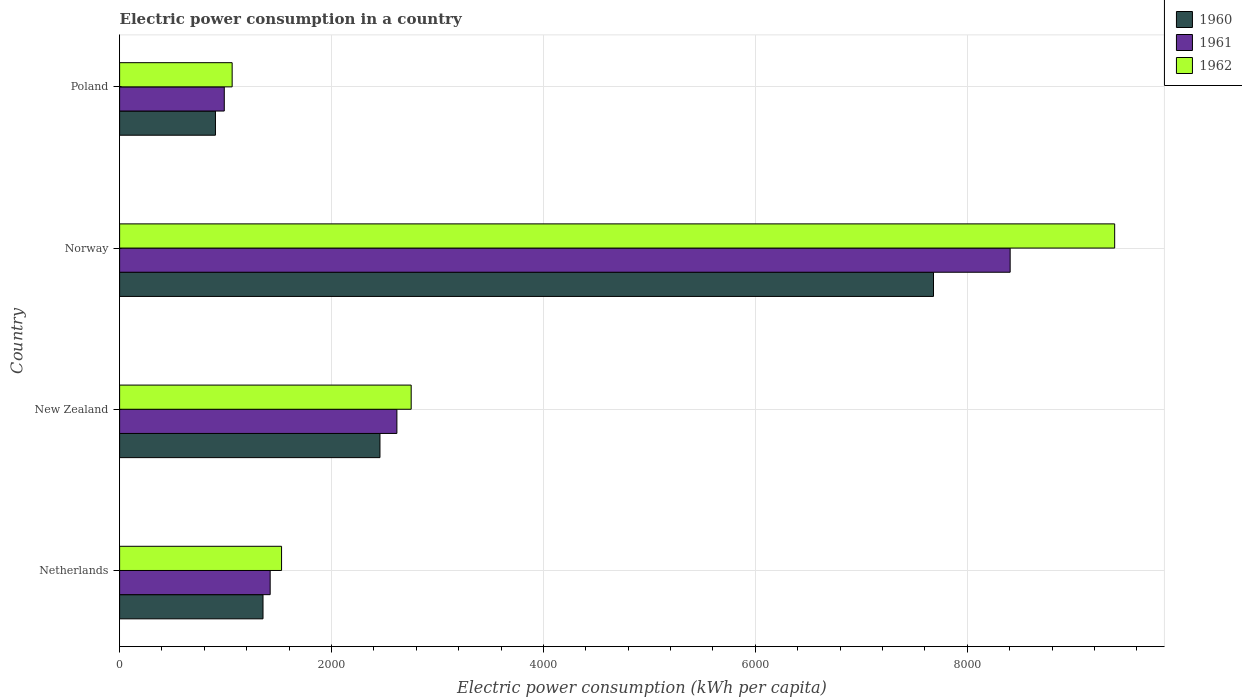How many bars are there on the 1st tick from the top?
Offer a very short reply. 3. What is the label of the 3rd group of bars from the top?
Ensure brevity in your answer.  New Zealand. What is the electric power consumption in in 1962 in Netherlands?
Your answer should be compact. 1528.5. Across all countries, what is the maximum electric power consumption in in 1961?
Your answer should be very brief. 8404.62. Across all countries, what is the minimum electric power consumption in in 1960?
Keep it short and to the point. 904.57. In which country was the electric power consumption in in 1961 maximum?
Give a very brief answer. Norway. In which country was the electric power consumption in in 1960 minimum?
Keep it short and to the point. Poland. What is the total electric power consumption in in 1962 in the graph?
Make the answer very short. 1.47e+04. What is the difference between the electric power consumption in in 1962 in Netherlands and that in Norway?
Ensure brevity in your answer.  -7862.48. What is the difference between the electric power consumption in in 1962 in Poland and the electric power consumption in in 1961 in Netherlands?
Give a very brief answer. -358.86. What is the average electric power consumption in in 1961 per country?
Provide a short and direct response. 3357.61. What is the difference between the electric power consumption in in 1962 and electric power consumption in in 1960 in New Zealand?
Provide a short and direct response. 294.61. What is the ratio of the electric power consumption in in 1962 in Netherlands to that in Norway?
Ensure brevity in your answer.  0.16. Is the electric power consumption in in 1960 in New Zealand less than that in Poland?
Ensure brevity in your answer.  No. What is the difference between the highest and the second highest electric power consumption in in 1961?
Offer a very short reply. 5787.77. What is the difference between the highest and the lowest electric power consumption in in 1961?
Offer a terse response. 7416.7. Is the sum of the electric power consumption in in 1960 in Netherlands and New Zealand greater than the maximum electric power consumption in in 1961 across all countries?
Your answer should be very brief. No. What does the 3rd bar from the top in New Zealand represents?
Make the answer very short. 1960. Is it the case that in every country, the sum of the electric power consumption in in 1961 and electric power consumption in in 1962 is greater than the electric power consumption in in 1960?
Provide a succinct answer. Yes. How many bars are there?
Ensure brevity in your answer.  12. Does the graph contain any zero values?
Your answer should be very brief. No. How are the legend labels stacked?
Give a very brief answer. Vertical. What is the title of the graph?
Provide a short and direct response. Electric power consumption in a country. What is the label or title of the X-axis?
Your response must be concise. Electric power consumption (kWh per capita). What is the Electric power consumption (kWh per capita) of 1960 in Netherlands?
Keep it short and to the point. 1353.4. What is the Electric power consumption (kWh per capita) in 1961 in Netherlands?
Offer a terse response. 1421.03. What is the Electric power consumption (kWh per capita) in 1962 in Netherlands?
Make the answer very short. 1528.5. What is the Electric power consumption (kWh per capita) in 1960 in New Zealand?
Your answer should be very brief. 2457.21. What is the Electric power consumption (kWh per capita) in 1961 in New Zealand?
Provide a short and direct response. 2616.85. What is the Electric power consumption (kWh per capita) of 1962 in New Zealand?
Your answer should be compact. 2751.81. What is the Electric power consumption (kWh per capita) of 1960 in Norway?
Provide a succinct answer. 7681.14. What is the Electric power consumption (kWh per capita) in 1961 in Norway?
Keep it short and to the point. 8404.62. What is the Electric power consumption (kWh per capita) in 1962 in Norway?
Offer a terse response. 9390.98. What is the Electric power consumption (kWh per capita) of 1960 in Poland?
Your answer should be compact. 904.57. What is the Electric power consumption (kWh per capita) in 1961 in Poland?
Your answer should be very brief. 987.92. What is the Electric power consumption (kWh per capita) of 1962 in Poland?
Your answer should be compact. 1062.18. Across all countries, what is the maximum Electric power consumption (kWh per capita) of 1960?
Make the answer very short. 7681.14. Across all countries, what is the maximum Electric power consumption (kWh per capita) of 1961?
Your answer should be compact. 8404.62. Across all countries, what is the maximum Electric power consumption (kWh per capita) in 1962?
Provide a succinct answer. 9390.98. Across all countries, what is the minimum Electric power consumption (kWh per capita) of 1960?
Your response must be concise. 904.57. Across all countries, what is the minimum Electric power consumption (kWh per capita) of 1961?
Your answer should be compact. 987.92. Across all countries, what is the minimum Electric power consumption (kWh per capita) of 1962?
Offer a very short reply. 1062.18. What is the total Electric power consumption (kWh per capita) of 1960 in the graph?
Your answer should be very brief. 1.24e+04. What is the total Electric power consumption (kWh per capita) in 1961 in the graph?
Offer a very short reply. 1.34e+04. What is the total Electric power consumption (kWh per capita) in 1962 in the graph?
Offer a terse response. 1.47e+04. What is the difference between the Electric power consumption (kWh per capita) of 1960 in Netherlands and that in New Zealand?
Your answer should be compact. -1103.81. What is the difference between the Electric power consumption (kWh per capita) of 1961 in Netherlands and that in New Zealand?
Provide a succinct answer. -1195.82. What is the difference between the Electric power consumption (kWh per capita) of 1962 in Netherlands and that in New Zealand?
Ensure brevity in your answer.  -1223.31. What is the difference between the Electric power consumption (kWh per capita) of 1960 in Netherlands and that in Norway?
Provide a succinct answer. -6327.74. What is the difference between the Electric power consumption (kWh per capita) of 1961 in Netherlands and that in Norway?
Give a very brief answer. -6983.59. What is the difference between the Electric power consumption (kWh per capita) of 1962 in Netherlands and that in Norway?
Give a very brief answer. -7862.48. What is the difference between the Electric power consumption (kWh per capita) of 1960 in Netherlands and that in Poland?
Your response must be concise. 448.83. What is the difference between the Electric power consumption (kWh per capita) in 1961 in Netherlands and that in Poland?
Ensure brevity in your answer.  433.11. What is the difference between the Electric power consumption (kWh per capita) in 1962 in Netherlands and that in Poland?
Provide a succinct answer. 466.32. What is the difference between the Electric power consumption (kWh per capita) in 1960 in New Zealand and that in Norway?
Give a very brief answer. -5223.94. What is the difference between the Electric power consumption (kWh per capita) of 1961 in New Zealand and that in Norway?
Your answer should be compact. -5787.77. What is the difference between the Electric power consumption (kWh per capita) of 1962 in New Zealand and that in Norway?
Your answer should be compact. -6639.17. What is the difference between the Electric power consumption (kWh per capita) in 1960 in New Zealand and that in Poland?
Provide a short and direct response. 1552.64. What is the difference between the Electric power consumption (kWh per capita) in 1961 in New Zealand and that in Poland?
Your answer should be very brief. 1628.93. What is the difference between the Electric power consumption (kWh per capita) in 1962 in New Zealand and that in Poland?
Provide a short and direct response. 1689.64. What is the difference between the Electric power consumption (kWh per capita) of 1960 in Norway and that in Poland?
Keep it short and to the point. 6776.58. What is the difference between the Electric power consumption (kWh per capita) of 1961 in Norway and that in Poland?
Your answer should be very brief. 7416.7. What is the difference between the Electric power consumption (kWh per capita) in 1962 in Norway and that in Poland?
Offer a terse response. 8328.8. What is the difference between the Electric power consumption (kWh per capita) of 1960 in Netherlands and the Electric power consumption (kWh per capita) of 1961 in New Zealand?
Your answer should be very brief. -1263.45. What is the difference between the Electric power consumption (kWh per capita) of 1960 in Netherlands and the Electric power consumption (kWh per capita) of 1962 in New Zealand?
Your answer should be compact. -1398.41. What is the difference between the Electric power consumption (kWh per capita) in 1961 in Netherlands and the Electric power consumption (kWh per capita) in 1962 in New Zealand?
Your answer should be compact. -1330.78. What is the difference between the Electric power consumption (kWh per capita) of 1960 in Netherlands and the Electric power consumption (kWh per capita) of 1961 in Norway?
Offer a terse response. -7051.22. What is the difference between the Electric power consumption (kWh per capita) of 1960 in Netherlands and the Electric power consumption (kWh per capita) of 1962 in Norway?
Your answer should be very brief. -8037.58. What is the difference between the Electric power consumption (kWh per capita) of 1961 in Netherlands and the Electric power consumption (kWh per capita) of 1962 in Norway?
Your answer should be compact. -7969.94. What is the difference between the Electric power consumption (kWh per capita) of 1960 in Netherlands and the Electric power consumption (kWh per capita) of 1961 in Poland?
Provide a succinct answer. 365.48. What is the difference between the Electric power consumption (kWh per capita) in 1960 in Netherlands and the Electric power consumption (kWh per capita) in 1962 in Poland?
Make the answer very short. 291.22. What is the difference between the Electric power consumption (kWh per capita) in 1961 in Netherlands and the Electric power consumption (kWh per capita) in 1962 in Poland?
Provide a short and direct response. 358.86. What is the difference between the Electric power consumption (kWh per capita) of 1960 in New Zealand and the Electric power consumption (kWh per capita) of 1961 in Norway?
Provide a succinct answer. -5947.42. What is the difference between the Electric power consumption (kWh per capita) in 1960 in New Zealand and the Electric power consumption (kWh per capita) in 1962 in Norway?
Give a very brief answer. -6933.77. What is the difference between the Electric power consumption (kWh per capita) of 1961 in New Zealand and the Electric power consumption (kWh per capita) of 1962 in Norway?
Your answer should be compact. -6774.12. What is the difference between the Electric power consumption (kWh per capita) of 1960 in New Zealand and the Electric power consumption (kWh per capita) of 1961 in Poland?
Give a very brief answer. 1469.29. What is the difference between the Electric power consumption (kWh per capita) of 1960 in New Zealand and the Electric power consumption (kWh per capita) of 1962 in Poland?
Provide a succinct answer. 1395.03. What is the difference between the Electric power consumption (kWh per capita) of 1961 in New Zealand and the Electric power consumption (kWh per capita) of 1962 in Poland?
Provide a short and direct response. 1554.68. What is the difference between the Electric power consumption (kWh per capita) of 1960 in Norway and the Electric power consumption (kWh per capita) of 1961 in Poland?
Your answer should be compact. 6693.22. What is the difference between the Electric power consumption (kWh per capita) in 1960 in Norway and the Electric power consumption (kWh per capita) in 1962 in Poland?
Your answer should be compact. 6618.96. What is the difference between the Electric power consumption (kWh per capita) in 1961 in Norway and the Electric power consumption (kWh per capita) in 1962 in Poland?
Give a very brief answer. 7342.44. What is the average Electric power consumption (kWh per capita) in 1960 per country?
Provide a short and direct response. 3099.08. What is the average Electric power consumption (kWh per capita) in 1961 per country?
Provide a short and direct response. 3357.61. What is the average Electric power consumption (kWh per capita) of 1962 per country?
Provide a short and direct response. 3683.37. What is the difference between the Electric power consumption (kWh per capita) in 1960 and Electric power consumption (kWh per capita) in 1961 in Netherlands?
Ensure brevity in your answer.  -67.63. What is the difference between the Electric power consumption (kWh per capita) in 1960 and Electric power consumption (kWh per capita) in 1962 in Netherlands?
Your answer should be compact. -175.1. What is the difference between the Electric power consumption (kWh per capita) in 1961 and Electric power consumption (kWh per capita) in 1962 in Netherlands?
Make the answer very short. -107.47. What is the difference between the Electric power consumption (kWh per capita) in 1960 and Electric power consumption (kWh per capita) in 1961 in New Zealand?
Make the answer very short. -159.65. What is the difference between the Electric power consumption (kWh per capita) in 1960 and Electric power consumption (kWh per capita) in 1962 in New Zealand?
Ensure brevity in your answer.  -294.61. What is the difference between the Electric power consumption (kWh per capita) in 1961 and Electric power consumption (kWh per capita) in 1962 in New Zealand?
Your answer should be very brief. -134.96. What is the difference between the Electric power consumption (kWh per capita) in 1960 and Electric power consumption (kWh per capita) in 1961 in Norway?
Keep it short and to the point. -723.48. What is the difference between the Electric power consumption (kWh per capita) in 1960 and Electric power consumption (kWh per capita) in 1962 in Norway?
Offer a very short reply. -1709.84. What is the difference between the Electric power consumption (kWh per capita) in 1961 and Electric power consumption (kWh per capita) in 1962 in Norway?
Make the answer very short. -986.36. What is the difference between the Electric power consumption (kWh per capita) in 1960 and Electric power consumption (kWh per capita) in 1961 in Poland?
Your response must be concise. -83.35. What is the difference between the Electric power consumption (kWh per capita) of 1960 and Electric power consumption (kWh per capita) of 1962 in Poland?
Keep it short and to the point. -157.61. What is the difference between the Electric power consumption (kWh per capita) of 1961 and Electric power consumption (kWh per capita) of 1962 in Poland?
Keep it short and to the point. -74.26. What is the ratio of the Electric power consumption (kWh per capita) of 1960 in Netherlands to that in New Zealand?
Offer a very short reply. 0.55. What is the ratio of the Electric power consumption (kWh per capita) of 1961 in Netherlands to that in New Zealand?
Make the answer very short. 0.54. What is the ratio of the Electric power consumption (kWh per capita) of 1962 in Netherlands to that in New Zealand?
Make the answer very short. 0.56. What is the ratio of the Electric power consumption (kWh per capita) in 1960 in Netherlands to that in Norway?
Your response must be concise. 0.18. What is the ratio of the Electric power consumption (kWh per capita) in 1961 in Netherlands to that in Norway?
Offer a terse response. 0.17. What is the ratio of the Electric power consumption (kWh per capita) of 1962 in Netherlands to that in Norway?
Give a very brief answer. 0.16. What is the ratio of the Electric power consumption (kWh per capita) of 1960 in Netherlands to that in Poland?
Provide a short and direct response. 1.5. What is the ratio of the Electric power consumption (kWh per capita) in 1961 in Netherlands to that in Poland?
Provide a succinct answer. 1.44. What is the ratio of the Electric power consumption (kWh per capita) in 1962 in Netherlands to that in Poland?
Your answer should be compact. 1.44. What is the ratio of the Electric power consumption (kWh per capita) of 1960 in New Zealand to that in Norway?
Keep it short and to the point. 0.32. What is the ratio of the Electric power consumption (kWh per capita) of 1961 in New Zealand to that in Norway?
Your answer should be very brief. 0.31. What is the ratio of the Electric power consumption (kWh per capita) in 1962 in New Zealand to that in Norway?
Give a very brief answer. 0.29. What is the ratio of the Electric power consumption (kWh per capita) in 1960 in New Zealand to that in Poland?
Your answer should be compact. 2.72. What is the ratio of the Electric power consumption (kWh per capita) in 1961 in New Zealand to that in Poland?
Keep it short and to the point. 2.65. What is the ratio of the Electric power consumption (kWh per capita) of 1962 in New Zealand to that in Poland?
Give a very brief answer. 2.59. What is the ratio of the Electric power consumption (kWh per capita) in 1960 in Norway to that in Poland?
Provide a succinct answer. 8.49. What is the ratio of the Electric power consumption (kWh per capita) of 1961 in Norway to that in Poland?
Make the answer very short. 8.51. What is the ratio of the Electric power consumption (kWh per capita) of 1962 in Norway to that in Poland?
Your answer should be compact. 8.84. What is the difference between the highest and the second highest Electric power consumption (kWh per capita) of 1960?
Give a very brief answer. 5223.94. What is the difference between the highest and the second highest Electric power consumption (kWh per capita) in 1961?
Your answer should be very brief. 5787.77. What is the difference between the highest and the second highest Electric power consumption (kWh per capita) in 1962?
Provide a succinct answer. 6639.17. What is the difference between the highest and the lowest Electric power consumption (kWh per capita) in 1960?
Offer a very short reply. 6776.58. What is the difference between the highest and the lowest Electric power consumption (kWh per capita) of 1961?
Your answer should be compact. 7416.7. What is the difference between the highest and the lowest Electric power consumption (kWh per capita) of 1962?
Provide a short and direct response. 8328.8. 